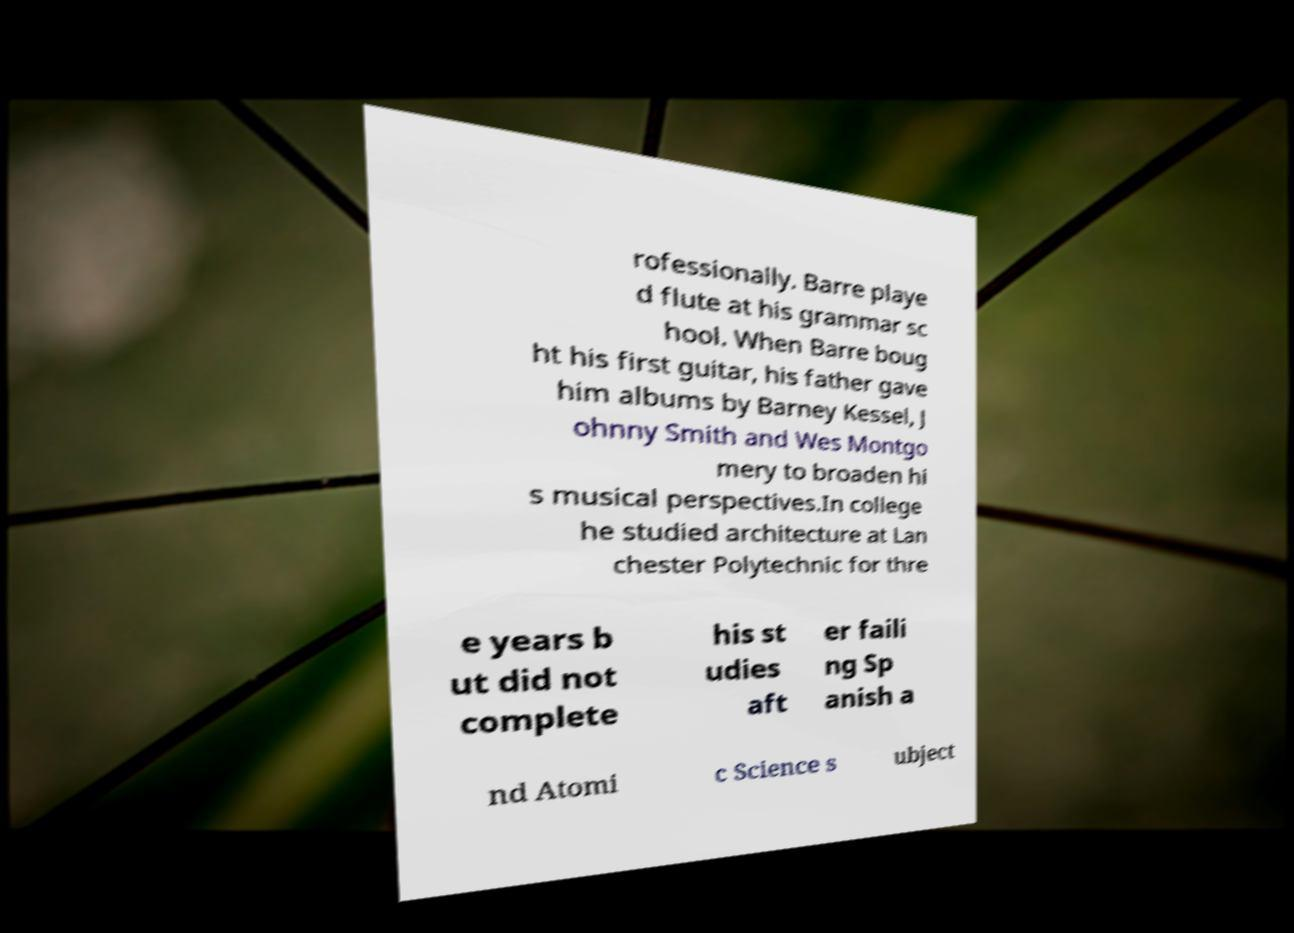Please identify and transcribe the text found in this image. rofessionally. Barre playe d flute at his grammar sc hool. When Barre boug ht his first guitar, his father gave him albums by Barney Kessel, J ohnny Smith and Wes Montgo mery to broaden hi s musical perspectives.In college he studied architecture at Lan chester Polytechnic for thre e years b ut did not complete his st udies aft er faili ng Sp anish a nd Atomi c Science s ubject 